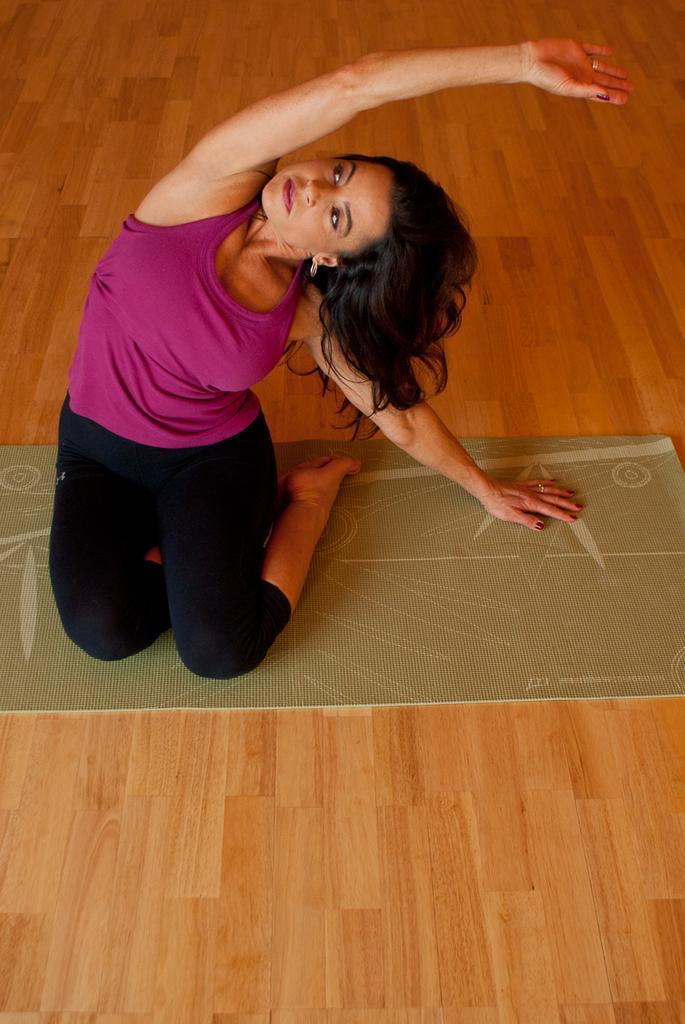Who is the person in the image? There is a woman in the image. What is the woman wearing? The woman is wearing a purple T-shirt. What activity is the woman engaged in? The woman is practicing yoga. What is the woman using to practice yoga? The woman is on a green color mat. What type of flooring is visible in the image? There is a wooden floor visible at the bottom of the image. Where is the receipt for the woman's yoga mat in the image? There is no receipt present in the image. What type of trucks can be seen in the background of the image? There are no trucks visible in the image. 